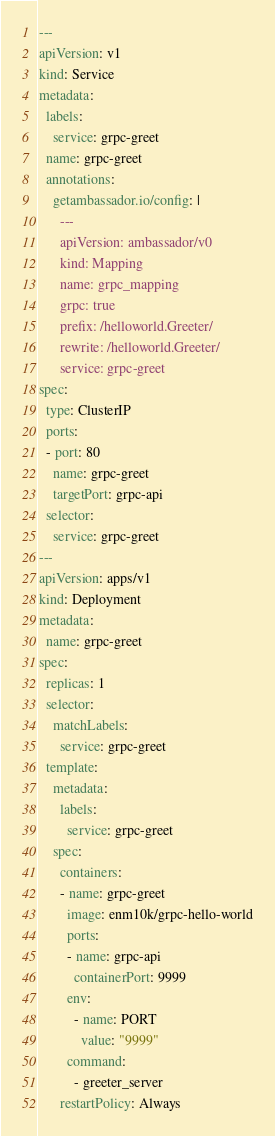<code> <loc_0><loc_0><loc_500><loc_500><_YAML_>---
apiVersion: v1
kind: Service
metadata:
  labels:
    service: grpc-greet
  name: grpc-greet
  annotations:
    getambassador.io/config: |
      ---
      apiVersion: ambassador/v0
      kind: Mapping
      name: grpc_mapping
      grpc: true
      prefix: /helloworld.Greeter/
      rewrite: /helloworld.Greeter/
      service: grpc-greet
spec:
  type: ClusterIP
  ports:
  - port: 80
    name: grpc-greet
    targetPort: grpc-api
  selector:
    service: grpc-greet
---
apiVersion: apps/v1
kind: Deployment
metadata:
  name: grpc-greet
spec:
  replicas: 1
  selector:
    matchLabels:
      service: grpc-greet
  template:
    metadata:
      labels:
        service: grpc-greet
    spec:
      containers:
      - name: grpc-greet
        image: enm10k/grpc-hello-world
        ports:
        - name: grpc-api
          containerPort: 9999
        env:
          - name: PORT
            value: "9999"
        command:
          - greeter_server
      restartPolicy: Always
</code> 